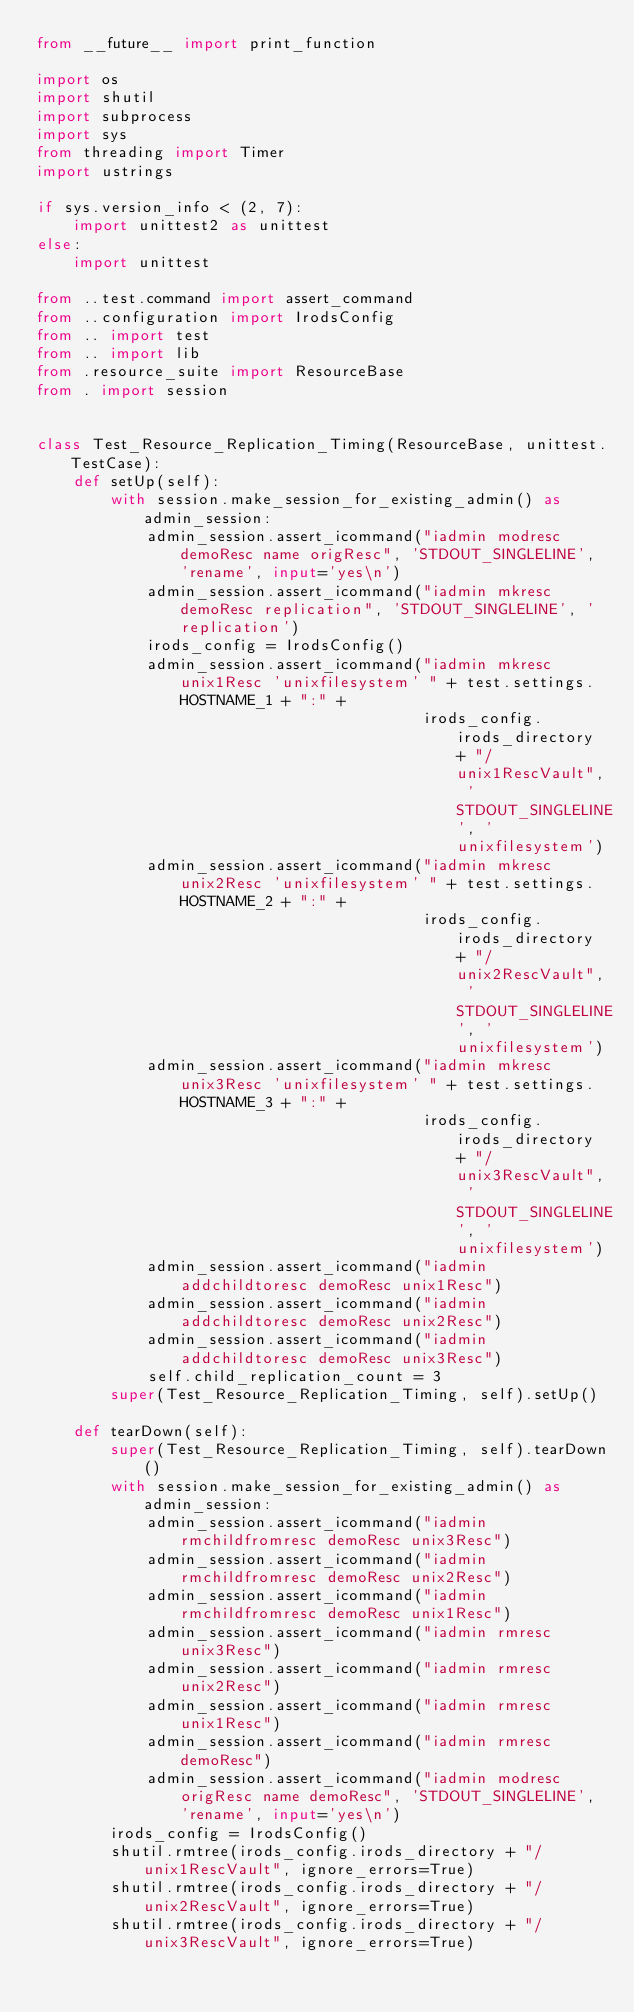Convert code to text. <code><loc_0><loc_0><loc_500><loc_500><_Python_>from __future__ import print_function

import os
import shutil
import subprocess
import sys
from threading import Timer
import ustrings

if sys.version_info < (2, 7):
    import unittest2 as unittest
else:
    import unittest

from ..test.command import assert_command
from ..configuration import IrodsConfig
from .. import test
from .. import lib
from .resource_suite import ResourceBase
from . import session


class Test_Resource_Replication_Timing(ResourceBase, unittest.TestCase):
    def setUp(self):
        with session.make_session_for_existing_admin() as admin_session:
            admin_session.assert_icommand("iadmin modresc demoResc name origResc", 'STDOUT_SINGLELINE', 'rename', input='yes\n')
            admin_session.assert_icommand("iadmin mkresc demoResc replication", 'STDOUT_SINGLELINE', 'replication')
            irods_config = IrodsConfig()
            admin_session.assert_icommand("iadmin mkresc unix1Resc 'unixfilesystem' " + test.settings.HOSTNAME_1 + ":" +
                                          irods_config.irods_directory + "/unix1RescVault", 'STDOUT_SINGLELINE', 'unixfilesystem')
            admin_session.assert_icommand("iadmin mkresc unix2Resc 'unixfilesystem' " + test.settings.HOSTNAME_2 + ":" +
                                          irods_config.irods_directory + "/unix2RescVault", 'STDOUT_SINGLELINE', 'unixfilesystem')
            admin_session.assert_icommand("iadmin mkresc unix3Resc 'unixfilesystem' " + test.settings.HOSTNAME_3 + ":" +
                                          irods_config.irods_directory + "/unix3RescVault", 'STDOUT_SINGLELINE', 'unixfilesystem')
            admin_session.assert_icommand("iadmin addchildtoresc demoResc unix1Resc")
            admin_session.assert_icommand("iadmin addchildtoresc demoResc unix2Resc")
            admin_session.assert_icommand("iadmin addchildtoresc demoResc unix3Resc")
            self.child_replication_count = 3
        super(Test_Resource_Replication_Timing, self).setUp()

    def tearDown(self):
        super(Test_Resource_Replication_Timing, self).tearDown()
        with session.make_session_for_existing_admin() as admin_session:
            admin_session.assert_icommand("iadmin rmchildfromresc demoResc unix3Resc")
            admin_session.assert_icommand("iadmin rmchildfromresc demoResc unix2Resc")
            admin_session.assert_icommand("iadmin rmchildfromresc demoResc unix1Resc")
            admin_session.assert_icommand("iadmin rmresc unix3Resc")
            admin_session.assert_icommand("iadmin rmresc unix2Resc")
            admin_session.assert_icommand("iadmin rmresc unix1Resc")
            admin_session.assert_icommand("iadmin rmresc demoResc")
            admin_session.assert_icommand("iadmin modresc origResc name demoResc", 'STDOUT_SINGLELINE', 'rename', input='yes\n')
        irods_config = IrodsConfig()
        shutil.rmtree(irods_config.irods_directory + "/unix1RescVault", ignore_errors=True)
        shutil.rmtree(irods_config.irods_directory + "/unix2RescVault", ignore_errors=True)
        shutil.rmtree(irods_config.irods_directory + "/unix3RescVault", ignore_errors=True)
</code> 